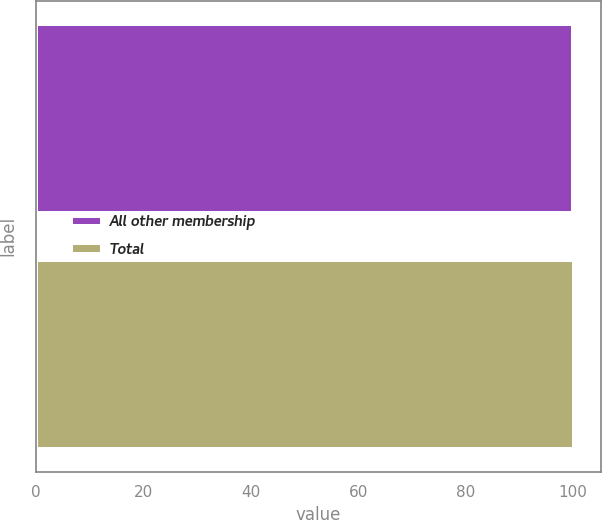<chart> <loc_0><loc_0><loc_500><loc_500><bar_chart><fcel>All other membership<fcel>Total<nl><fcel>100<fcel>100.1<nl></chart> 